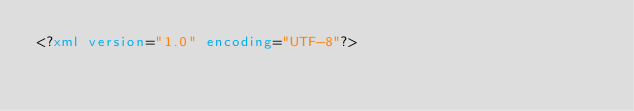Convert code to text. <code><loc_0><loc_0><loc_500><loc_500><_XML_><?xml version="1.0" encoding="UTF-8"?></code> 